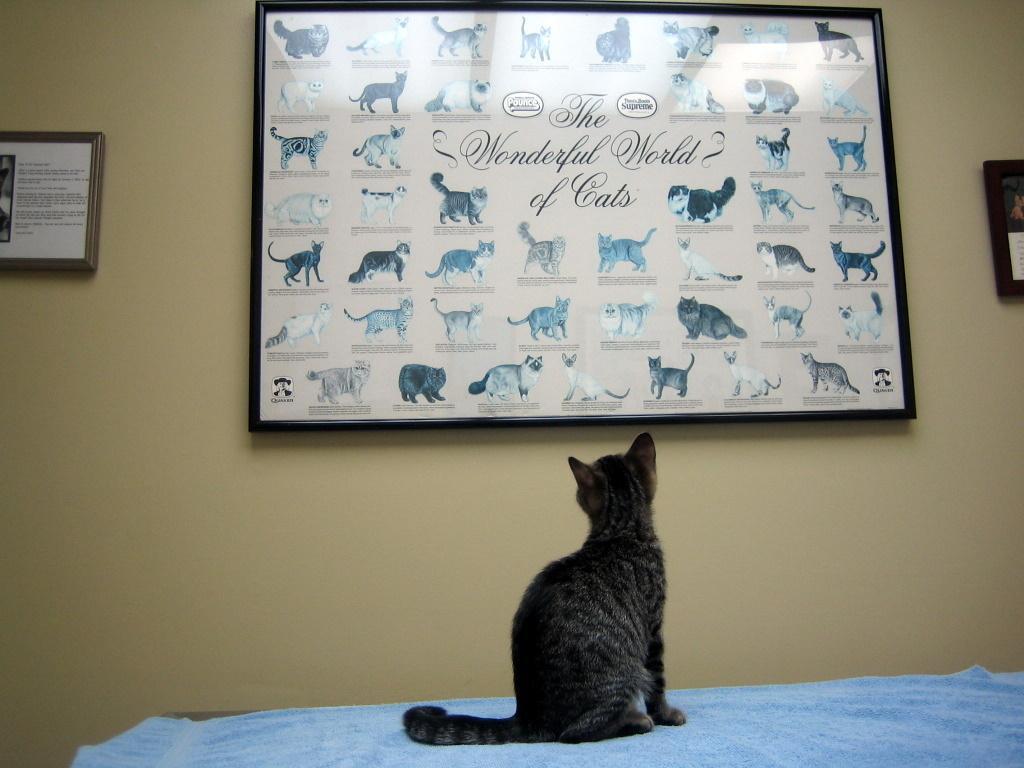In one or two sentences, can you explain what this image depicts? In this picture I can see a blue color cloth on which there is a cat sitting and in the background I can see the wall, on which there are 3 frames and on the middle frame, I can see the pictures of cats and I see something is written. 